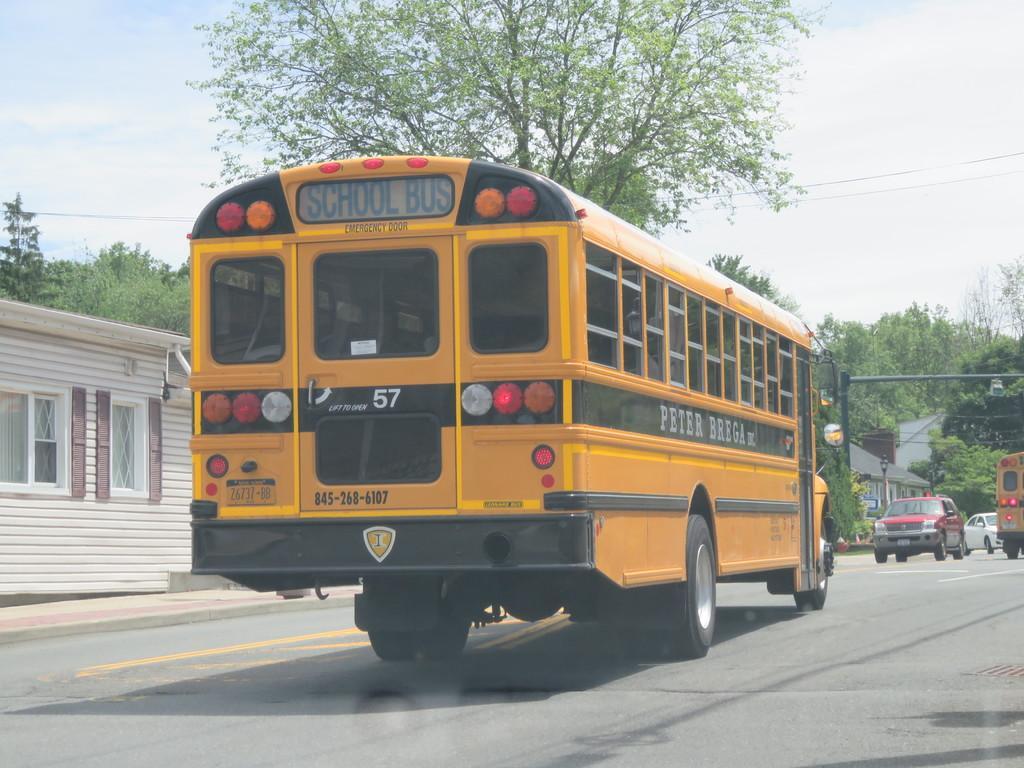Please provide a concise description of this image. In this picture, we see the bus in yellow and black color is moving on the road. On the right side, we see the vehicles are moving on the road. Beside that, we see a pole. On the left side, we see a building in white color. It has the windows. Behind that, we see the trees. There are trees, poles and buildings in the background. At the top, we see the sky. At the bottom, we see the road. 